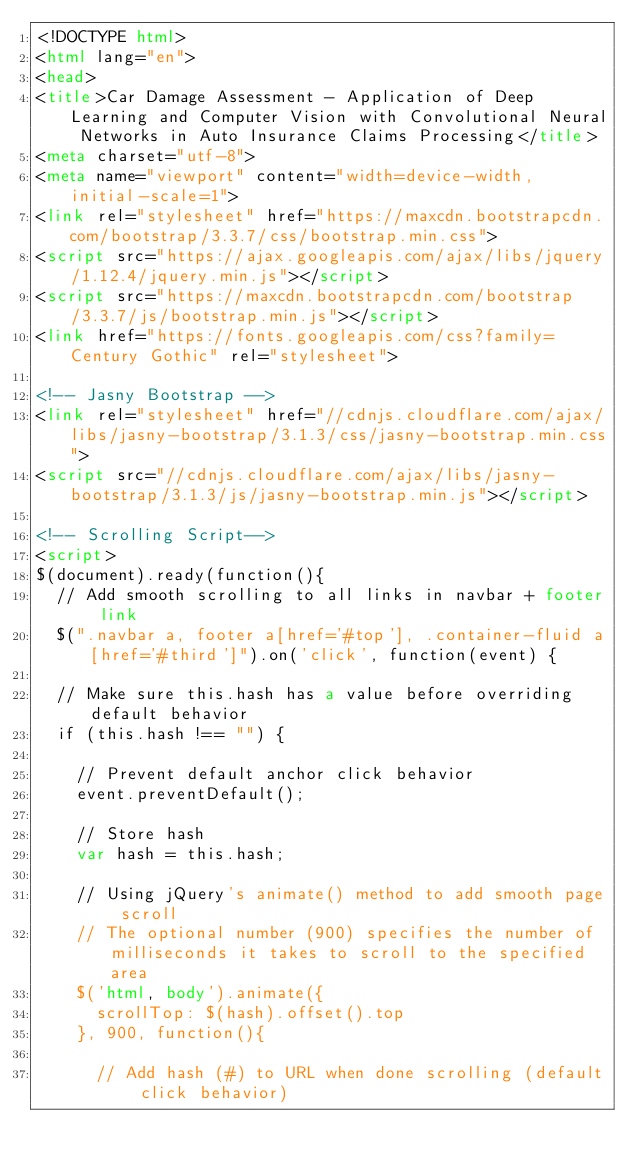Convert code to text. <code><loc_0><loc_0><loc_500><loc_500><_HTML_><!DOCTYPE html>
<html lang="en">
<head>
<title>Car Damage Assessment - Application of Deep Learning and Computer Vision with Convolutional Neural Networks in Auto Insurance Claims Processing</title>
<meta charset="utf-8">
<meta name="viewport" content="width=device-width, initial-scale=1">
<link rel="stylesheet" href="https://maxcdn.bootstrapcdn.com/bootstrap/3.3.7/css/bootstrap.min.css">
<script src="https://ajax.googleapis.com/ajax/libs/jquery/1.12.4/jquery.min.js"></script>
<script src="https://maxcdn.bootstrapcdn.com/bootstrap/3.3.7/js/bootstrap.min.js"></script>
<link href="https://fonts.googleapis.com/css?family=Century Gothic" rel="stylesheet">

<!-- Jasny Bootstrap -->
<link rel="stylesheet" href="//cdnjs.cloudflare.com/ajax/libs/jasny-bootstrap/3.1.3/css/jasny-bootstrap.min.css">
<script src="//cdnjs.cloudflare.com/ajax/libs/jasny-bootstrap/3.1.3/js/jasny-bootstrap.min.js"></script>

<!-- Scrolling Script-->
<script>
$(document).ready(function(){
  // Add smooth scrolling to all links in navbar + footer link
  $(".navbar a, footer a[href='#top'], .container-fluid a[href='#third']").on('click', function(event) {

  // Make sure this.hash has a value before overriding default behavior
  if (this.hash !== "") {

    // Prevent default anchor click behavior
    event.preventDefault();

    // Store hash
    var hash = this.hash;

    // Using jQuery's animate() method to add smooth page scroll
    // The optional number (900) specifies the number of milliseconds it takes to scroll to the specified area
    $('html, body').animate({
      scrollTop: $(hash).offset().top
    }, 900, function(){

      // Add hash (#) to URL when done scrolling (default click behavior)</code> 